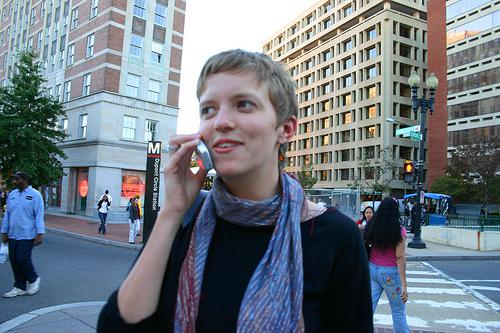Question: what is the woman holding?
Choices:
A. Pencil.
B. A cell phone.
C. Briefcase.
D. Pistol.
Answer with the letter. Answer: B Question: who is talking on the phone?
Choices:
A. The woman who is bleeding.
B. The woman who gave birth.
C. The woman who was elected.
D. The woman facing the camera.
Answer with the letter. Answer: D Question: when was the photo taken?
Choices:
A. During Happy hour.
B. During the day.
C. During sunset.
D. During lunch break.
Answer with the letter. Answer: B Question: where is the man walking?
Choices:
A. On the sidewalk.
B. On the side of the road.
C. On the middle median.
D. In the street.
Answer with the letter. Answer: D Question: what color is the neon sign?
Choices:
A. Red.
B. Yellow.
C. Green.
D. Blue.
Answer with the letter. Answer: A 